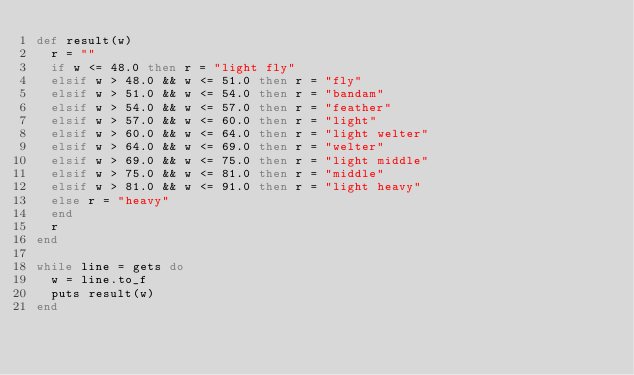<code> <loc_0><loc_0><loc_500><loc_500><_Ruby_>def result(w)
  r = ""
  if w <= 48.0 then r = "light fly"
  elsif w > 48.0 && w <= 51.0 then r = "fly"
  elsif w > 51.0 && w <= 54.0 then r = "bandam"
  elsif w > 54.0 && w <= 57.0 then r = "feather"
  elsif w > 57.0 && w <= 60.0 then r = "light"
  elsif w > 60.0 && w <= 64.0 then r = "light welter"
  elsif w > 64.0 && w <= 69.0 then r = "welter"
  elsif w > 69.0 && w <= 75.0 then r = "light middle"
  elsif w > 75.0 && w <= 81.0 then r = "middle"
  elsif w > 81.0 && w <= 91.0 then r = "light heavy"
  else r = "heavy"
  end
  r
end

while line = gets do
  w = line.to_f
  puts result(w)
end
</code> 